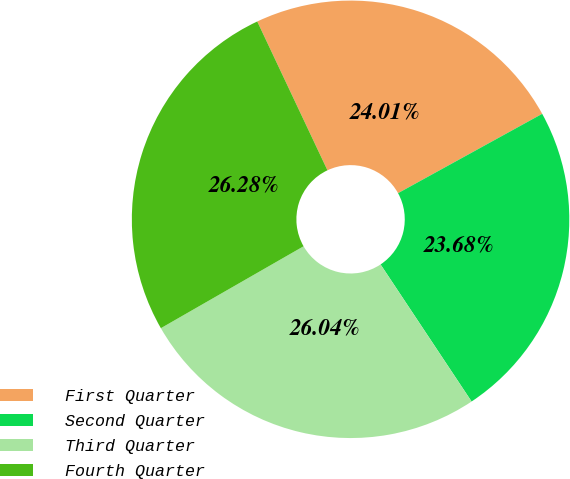Convert chart to OTSL. <chart><loc_0><loc_0><loc_500><loc_500><pie_chart><fcel>First Quarter<fcel>Second Quarter<fcel>Third Quarter<fcel>Fourth Quarter<nl><fcel>24.01%<fcel>23.68%<fcel>26.04%<fcel>26.28%<nl></chart> 